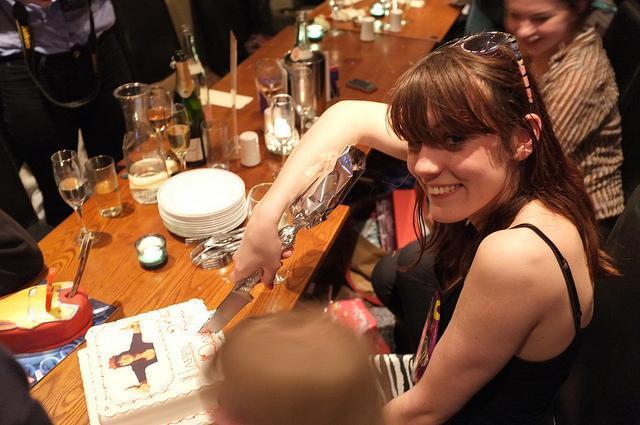How many people are there?
Give a very brief answer. 4. How many dining tables are there?
Give a very brief answer. 1. How many chairs are in the picture?
Give a very brief answer. 2. How many cakes can be seen?
Give a very brief answer. 2. How many giraffes are there?
Give a very brief answer. 0. 